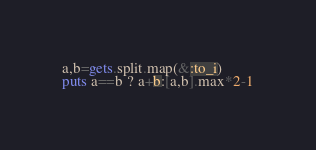<code> <loc_0><loc_0><loc_500><loc_500><_Ruby_>a,b=gets.split.map(&:to_i)
puts a==b ? a+b:[a,b].max*2-1
</code> 